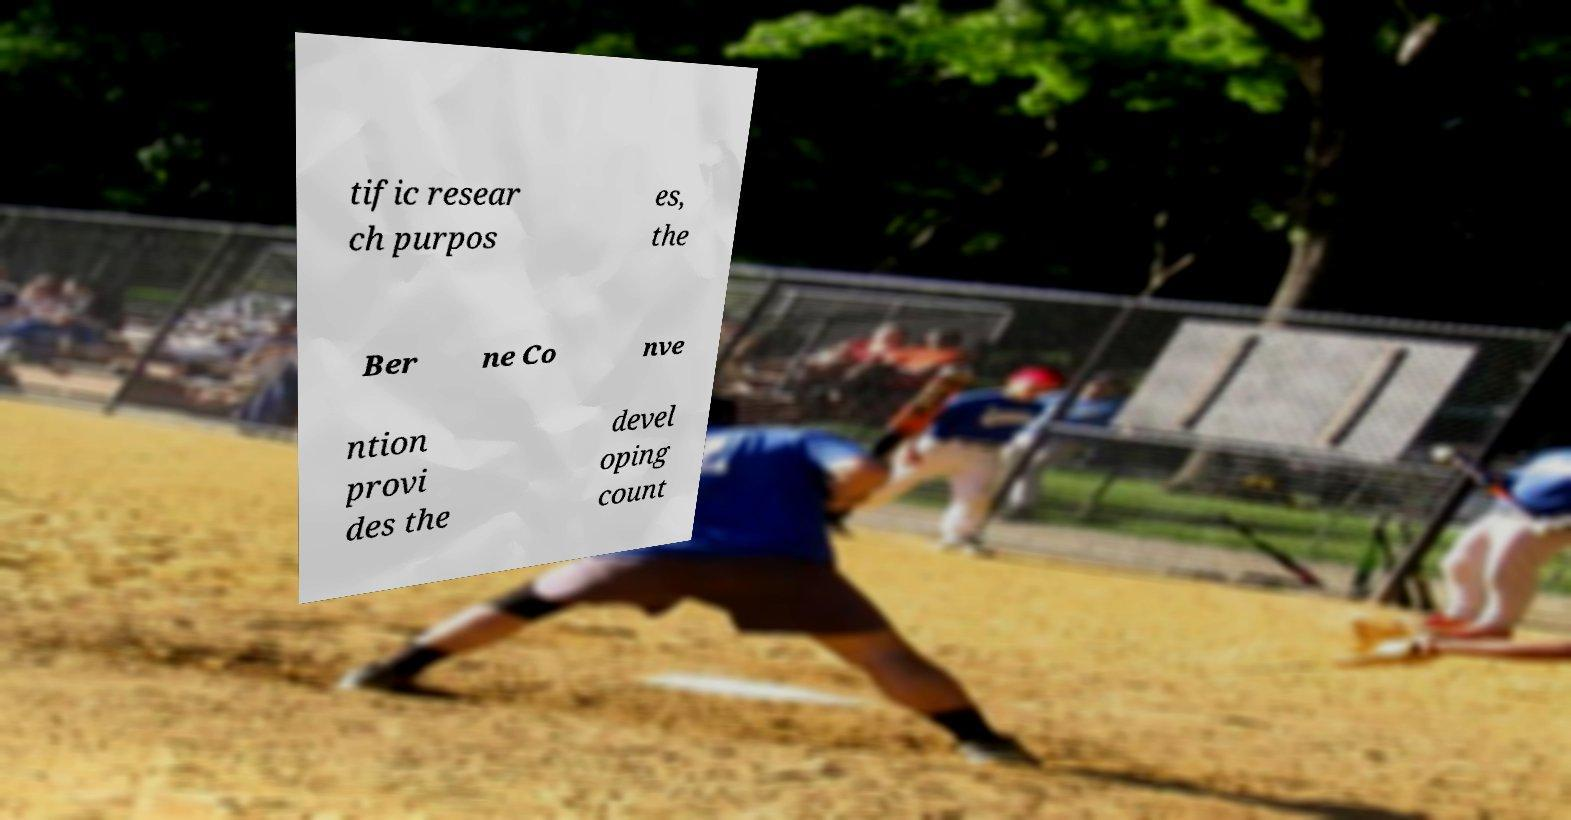Could you extract and type out the text from this image? tific resear ch purpos es, the Ber ne Co nve ntion provi des the devel oping count 